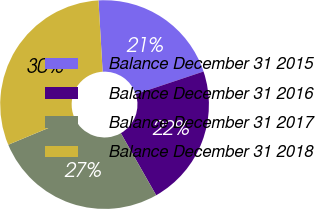<chart> <loc_0><loc_0><loc_500><loc_500><pie_chart><fcel>Balance December 31 2015<fcel>Balance December 31 2016<fcel>Balance December 31 2017<fcel>Balance December 31 2018<nl><fcel>20.8%<fcel>21.9%<fcel>26.95%<fcel>30.36%<nl></chart> 